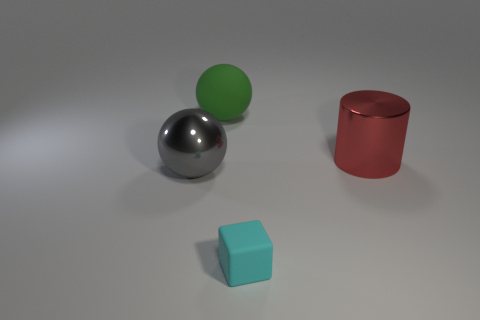Add 1 large green objects. How many objects exist? 5 Subtract 0 green blocks. How many objects are left? 4 Subtract all cylinders. How many objects are left? 3 Subtract all big red objects. Subtract all tiny rubber cubes. How many objects are left? 2 Add 4 tiny matte things. How many tiny matte things are left? 5 Add 4 tiny cyan blocks. How many tiny cyan blocks exist? 5 